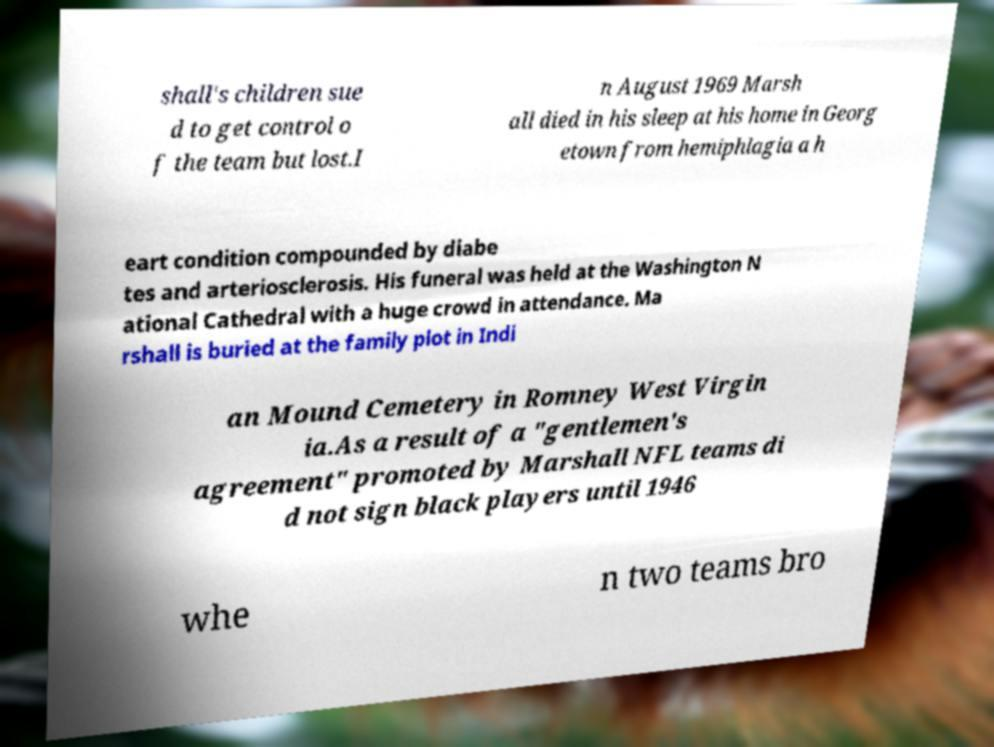Could you assist in decoding the text presented in this image and type it out clearly? shall's children sue d to get control o f the team but lost.I n August 1969 Marsh all died in his sleep at his home in Georg etown from hemiphlagia a h eart condition compounded by diabe tes and arteriosclerosis. His funeral was held at the Washington N ational Cathedral with a huge crowd in attendance. Ma rshall is buried at the family plot in Indi an Mound Cemetery in Romney West Virgin ia.As a result of a "gentlemen's agreement" promoted by Marshall NFL teams di d not sign black players until 1946 whe n two teams bro 